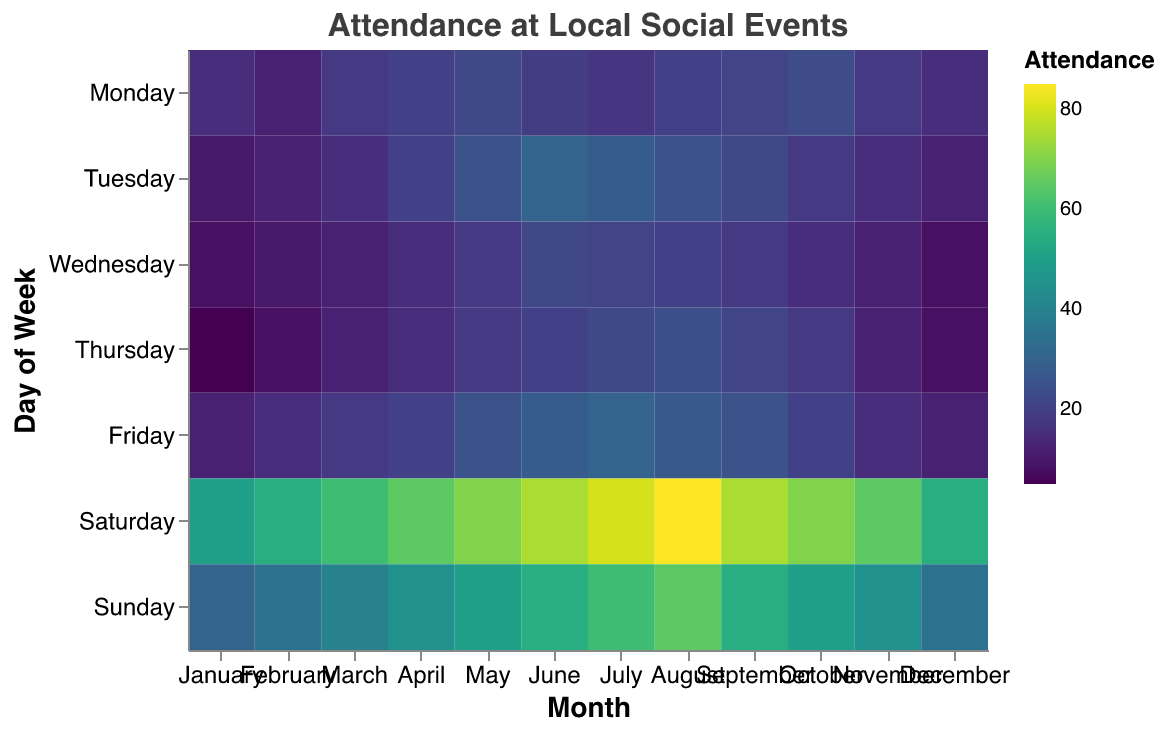What is the highest attendance recorded for a Coffee Morning? Looking at the heatmap, the highest attendance for "Coffee Morning" is marked by the darkest color on a Tuesday in June. The tooltip confirms it as 30.
Answer: 30 Which month has the highest average attendance for the Local Market? For the Local Market event on Saturdays, we check the average of attendance across all months. August has the darkest shade indicating the highest average; the tooltip confirms 85.
Answer: August How does attendance for Book Club in January compare to December? By comparing the color shades for Mondays in January and December, both months show a similar color intensity. The tooltip shows that attendance is 15 for both months.
Answer: Equal What is the most attended weekday event and in which month does it occur? The most attended weekday event would have the darkest color on any weekday. By scanning for the darkest color, "Local Market" on Saturdays in August with 85 stands out as the highest attendance.
Answer: Local Market in August Which event shows a consistent increase in attendance from January to August? By examining each event’s attendance progression, Park Run on Sundays shows a consistent color darkening from January to August, indicating a steady increase in attendance.
Answer: Park Run What's the difference in attendance between Community Gardening in July and December? By referring to the heatmap for Community Gardening on Thursdays, the shade differences are notable. The tooltip reveals attendance of 22 in July and 8 in December. The difference is 22 - 8.
Answer: 14 Which day of the week has the most variable attendance throughout the year? Observing the color variations across the days, Sunday (Park Run) shows significant changes in attendance month to month, indicating high variability.
Answer: Sunday Compare the average attendance in February for Yoga Class and Pilates Class. We look at the attendance values: 10 for Yoga Class on Wednesday in February and 15 for Pilates Class on Friday in February. The average is (10+15)/2.
Answer: 12.5 Does attendance at Local Market peak in summer? By checking the summer months (June, July, August) for Saturdays, we see the darkest colors, indicating that attendance is highest in these months, peaking in August.
Answer: Yes 